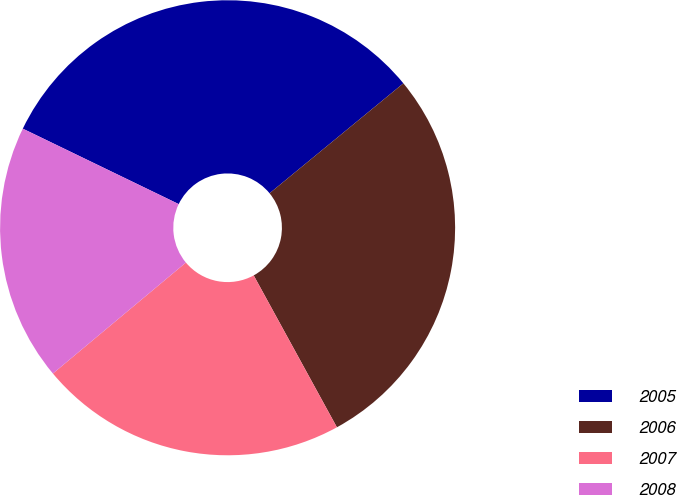Convert chart to OTSL. <chart><loc_0><loc_0><loc_500><loc_500><pie_chart><fcel>2005<fcel>2006<fcel>2007<fcel>2008<nl><fcel>31.88%<fcel>27.97%<fcel>21.91%<fcel>18.24%<nl></chart> 